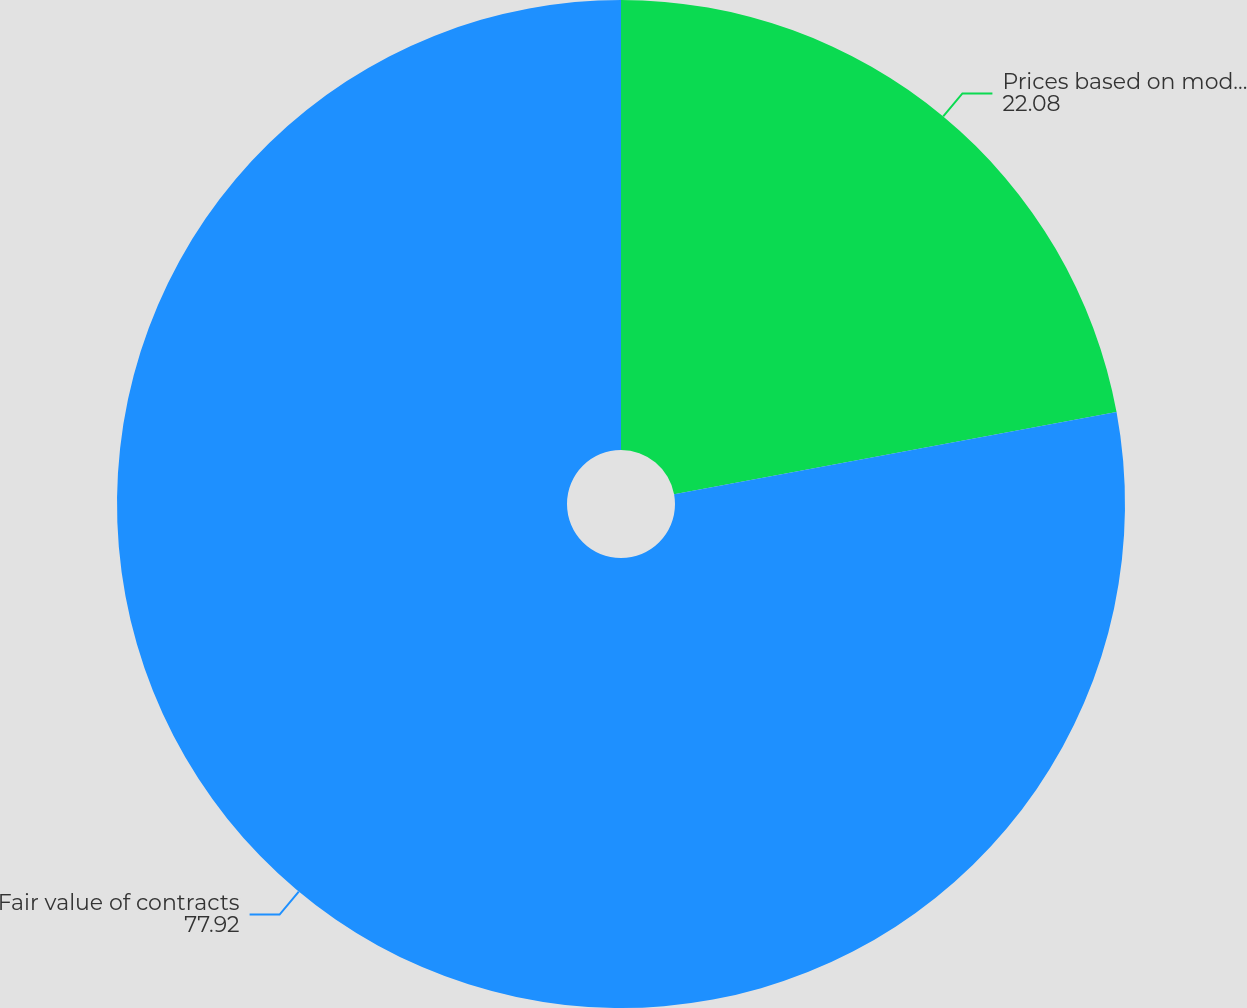<chart> <loc_0><loc_0><loc_500><loc_500><pie_chart><fcel>Prices based on models and<fcel>Fair value of contracts<nl><fcel>22.08%<fcel>77.92%<nl></chart> 